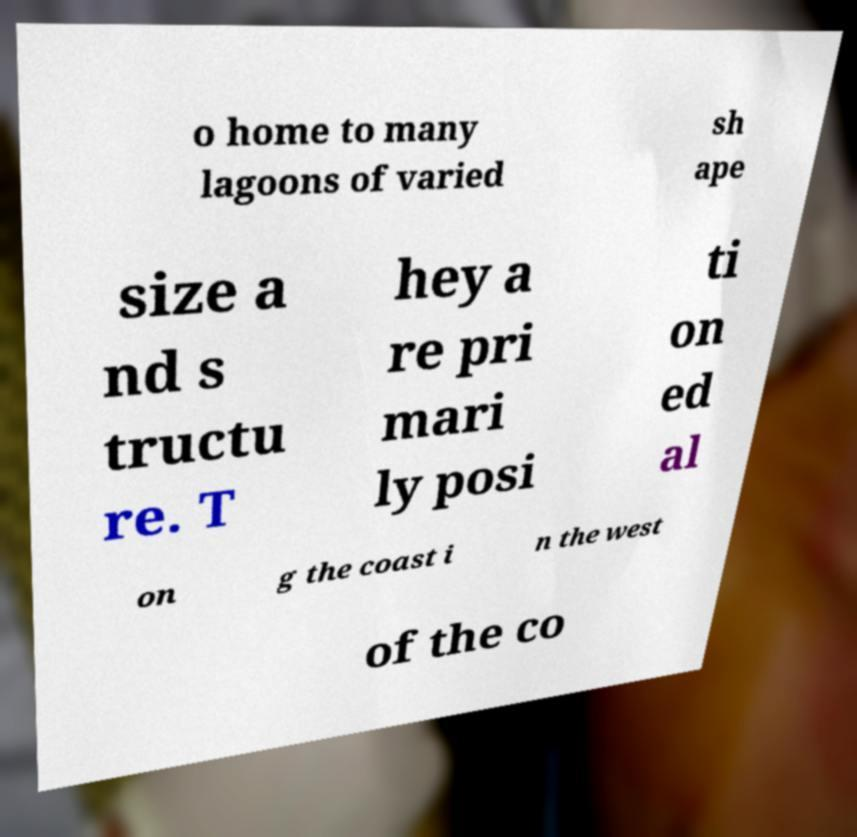Could you assist in decoding the text presented in this image and type it out clearly? o home to many lagoons of varied sh ape size a nd s tructu re. T hey a re pri mari ly posi ti on ed al on g the coast i n the west of the co 